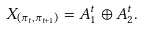<formula> <loc_0><loc_0><loc_500><loc_500>X _ { ( \pi _ { t } , \pi _ { t + 1 } ) } = A ^ { t } _ { 1 } \oplus A ^ { t } _ { 2 } .</formula> 